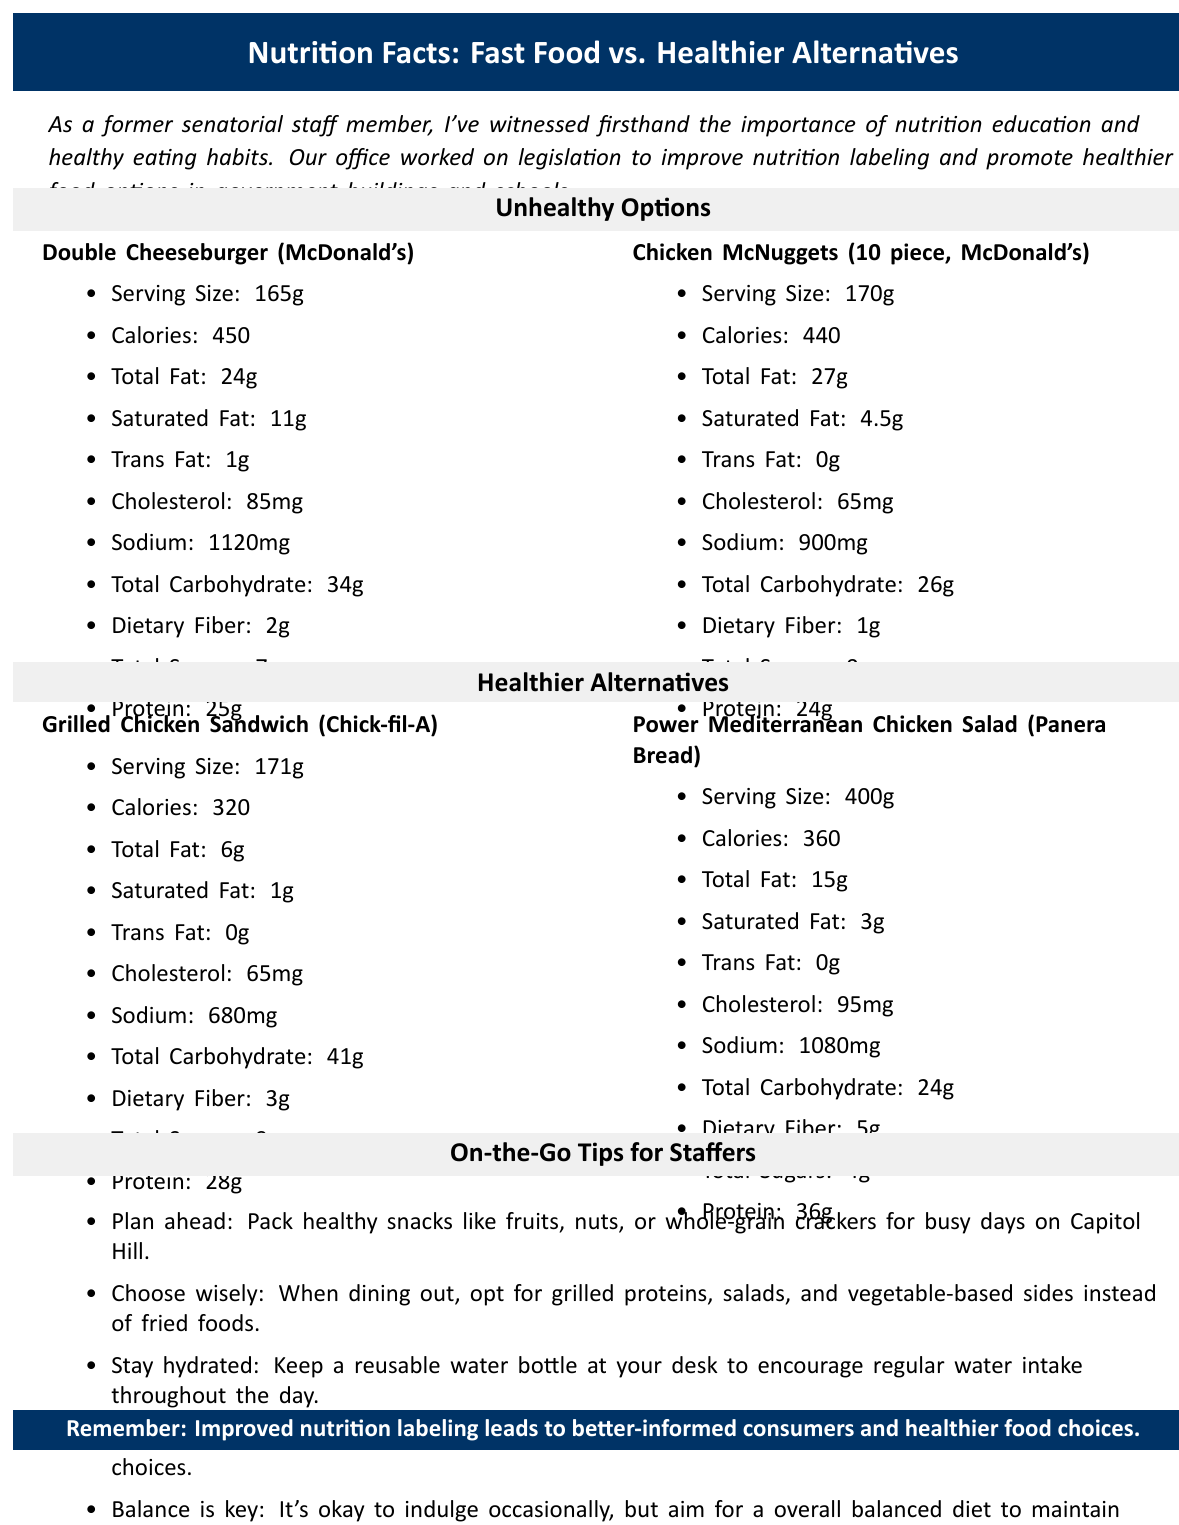what is the serving size of the Double Cheeseburger from McDonald's? The document lists the serving size for the Double Cheeseburger from McDonald's as 165g.
Answer: 165g how much total fat does the Chicken McNuggets have? The Chicken McNuggets (10 piece, McDonald's) contain 27g of total fat as mentioned in the document.
Answer: 27g what are the sodium levels in the Power Mediterranean Chicken Salad from Panera Bread? According to the document, the Power Mediterranean Chicken Salad from Panera Bread has 1080mg of sodium.
Answer: 1080mg Identify two healthier alternatives mentioned in the document. The document categorizes Grilled Chicken Sandwich from Chick-fil-A and Power Mediterranean Chicken Salad from Panera Bread as healthier alternatives.
Answer: Grilled Chicken Sandwich (Chick-fil-A), Power Mediterranean Chicken Salad (Panera Bread) what are the total carbohydrates in the Grilled Chicken Sandwich from Chick-fil-A? As per the document, the Grilled Chicken Sandwich from Chick-fil-A contains 41g of total carbohydrates.
Answer: 41g which food option has the highest protein content?
A. Double Cheeseburger (McDonald's)
B. Chicken McNuggets (10 piece, McDonald's)
C. Grilled Chicken Sandwich (Chick-fil-A)
D. Power Mediterranean Chicken Salad (Panera Bread) The Power Mediterranean Chicken Salad from Panera Bread has the highest protein content at 36g.
Answer: D which serving size is the largest?
A. Double Cheeseburger (McDonald's)
B. Chicken McNuggets (10 piece, McDonald's)
C. Grilled Chicken Sandwich (Chick-fil-A)
D. Power Mediterranean Chicken Salad (Panera Bread) The Power Mediterranean Chicken Salad from Panera Bread has the largest serving size at 400g.
Answer: D is the calorie content of the Grilled Chicken Sandwich from Chick-fil-A higher than the Double Cheeseburger from McDonald's? The Grilled Chicken Sandwich has 320 calories, while the Double Cheeseburger has 450 calories.
Answer: No summarize the main idea of the document. The document contains nutritional information of two unhealthy and two healthier food options, advice for staffers on maintaining healthy eating habits while busy, and an emphasis on the benefits of improved nutrition labeling and policies for promoting healthy food choices.
Answer: The document compares the nutritional facts of unhealthy fast food options and healthier alternatives for on-the-go staff members, emphasizing the importance of nutrition education, healthy eating habits, and providing specific legislative context and practical healthy eating tips for staffers. how much iron does the Double Cheeseburger from McDonald's contain? The document lists the iron content of the Double Cheeseburger from McDonald's as 3.6mg.
Answer: 3.6mg according to the document, what is the total sugar content in the Chicken McNuggets? The document notes that Chicken McNuggets (10 piece, McDonald's) contain 0g of total sugars.
Answer: 0g which food item has the least amount of saturated fat? The Grilled Chicken Sandwich has the least amount of saturated fat at 1g.
Answer: Grilled Chicken Sandwich (Chick-fil-A) does the Power Mediterranean Chicken Salad from Panera Bread have more total fat than the Double Cheeseburger from McDonald's? The Power Mediterranean Chicken Salad has 15g of total fat, whereas the Double Cheeseburger has 24g, so the salad has less total fat.
Answer: No how many on-the-go tips are provided in the document? The document lists five tips for maintaining healthy eating habits while on the go.
Answer: 5 what is the impact of improved nutrition labeling according to the document? The document states that improved nutrition labeling can help consumers make better, healthier food choices.
Answer: Improved nutrition labeling leads to better-informed consumers and healthier food choices. how much calcium is in the Chicken McNuggets from McDonald's? The document indicates that there are 20mg of calcium in the Chicken McNuggets from McDonald's.
Answer: 20mg what is the main legislative goal highlighted in the document? The document mentions that the main legislative goal observed by the former senatorial staffer involves improving nutrition labeling and promoting healthier food options in government buildings and schools.
Answer: Improving nutrition labeling and promoting healthier food options. 